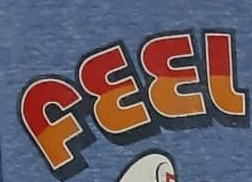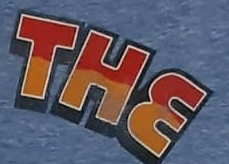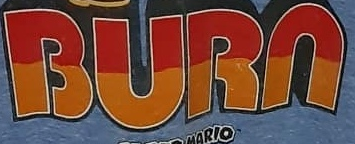What words can you see in these images in sequence, separated by a semicolon? FEEL; THE; BURN 